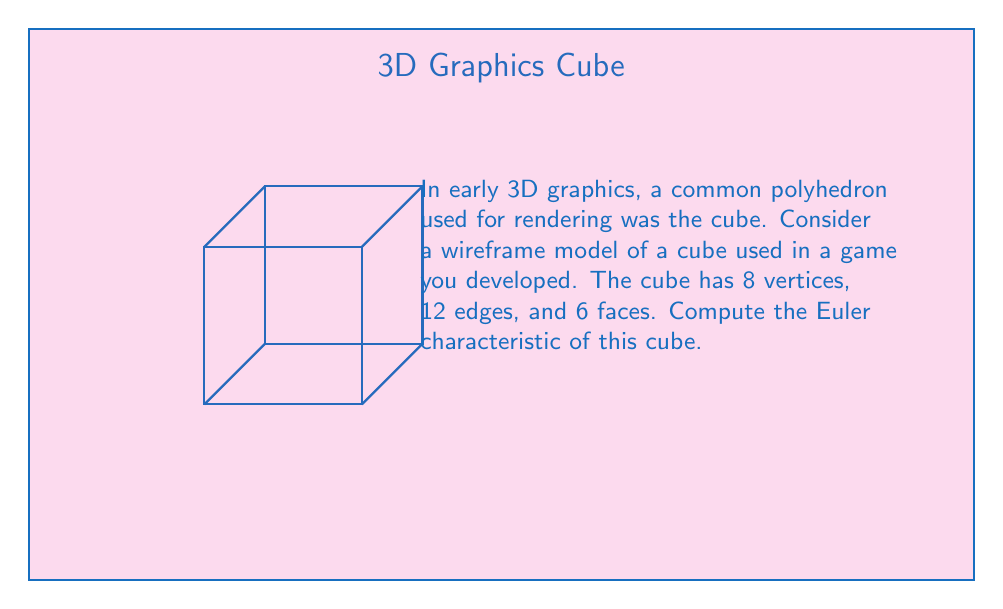Solve this math problem. To compute the Euler characteristic of the cube, we'll follow these steps:

1) Recall the formula for the Euler characteristic:
   $$\chi = V - E + F$$
   where $\chi$ is the Euler characteristic, $V$ is the number of vertices, $E$ is the number of edges, and $F$ is the number of faces.

2) From the given information:
   - Number of vertices (V) = 8
   - Number of edges (E) = 12
   - Number of faces (F) = 6

3) Substitute these values into the formula:
   $$\chi = 8 - 12 + 6$$

4) Simplify:
   $$\chi = 2$$

This result is consistent with the fact that the Euler characteristic is a topological invariant. For any convex polyhedron (which includes the cube), the Euler characteristic is always 2.

In early 3D graphics, understanding this property was crucial for efficient rendering and manipulation of 3D objects, as it allowed developers to optimize algorithms for vertex, edge, and face computations.
Answer: $\chi = 2$ 